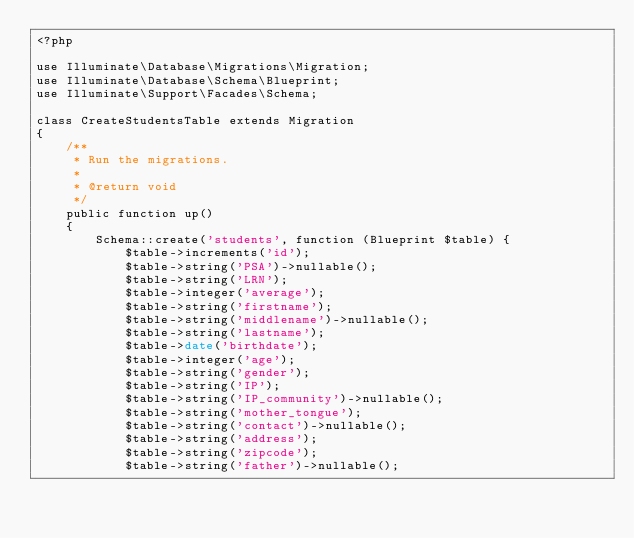Convert code to text. <code><loc_0><loc_0><loc_500><loc_500><_PHP_><?php

use Illuminate\Database\Migrations\Migration;
use Illuminate\Database\Schema\Blueprint;
use Illuminate\Support\Facades\Schema;

class CreateStudentsTable extends Migration
{
    /**
     * Run the migrations.
     *
     * @return void
     */
    public function up()
    {
        Schema::create('students', function (Blueprint $table) {
            $table->increments('id');
            $table->string('PSA')->nullable();
            $table->string('LRN');
            $table->integer('average');
            $table->string('firstname');
            $table->string('middlename')->nullable();
            $table->string('lastname');
            $table->date('birthdate');
            $table->integer('age');
            $table->string('gender');
            $table->string('IP');
            $table->string('IP_community')->nullable();
            $table->string('mother_tongue');
            $table->string('contact')->nullable();
            $table->string('address');
            $table->string('zipcode');
            $table->string('father')->nullable();</code> 